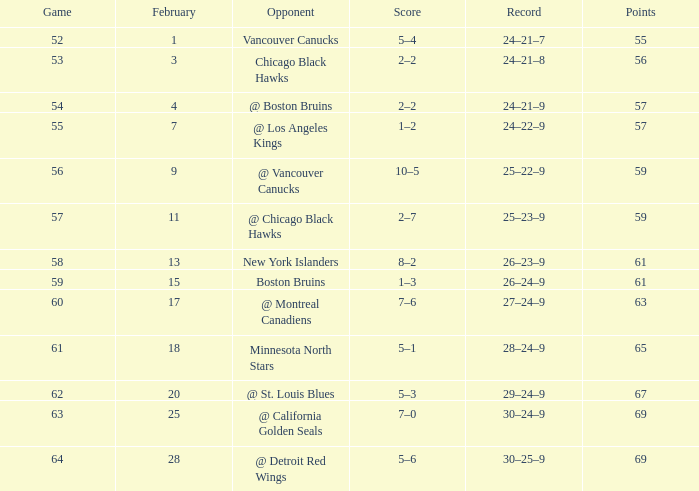In february, how many games had a 29-24-9 record? 20.0. 